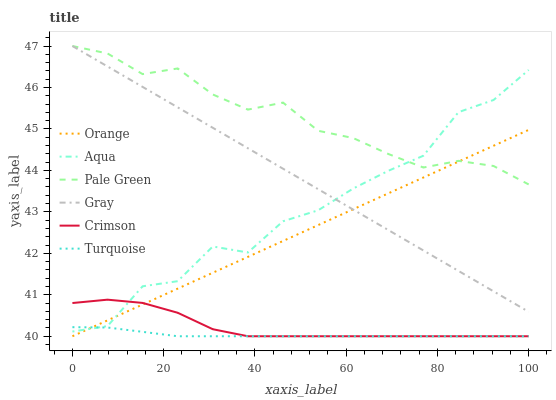Does Turquoise have the minimum area under the curve?
Answer yes or no. Yes. Does Pale Green have the maximum area under the curve?
Answer yes or no. Yes. Does Aqua have the minimum area under the curve?
Answer yes or no. No. Does Aqua have the maximum area under the curve?
Answer yes or no. No. Is Gray the smoothest?
Answer yes or no. Yes. Is Aqua the roughest?
Answer yes or no. Yes. Is Turquoise the smoothest?
Answer yes or no. No. Is Turquoise the roughest?
Answer yes or no. No. Does Turquoise have the lowest value?
Answer yes or no. Yes. Does Aqua have the lowest value?
Answer yes or no. No. Does Pale Green have the highest value?
Answer yes or no. Yes. Does Aqua have the highest value?
Answer yes or no. No. Is Crimson less than Pale Green?
Answer yes or no. Yes. Is Gray greater than Crimson?
Answer yes or no. Yes. Does Orange intersect Turquoise?
Answer yes or no. Yes. Is Orange less than Turquoise?
Answer yes or no. No. Is Orange greater than Turquoise?
Answer yes or no. No. Does Crimson intersect Pale Green?
Answer yes or no. No. 